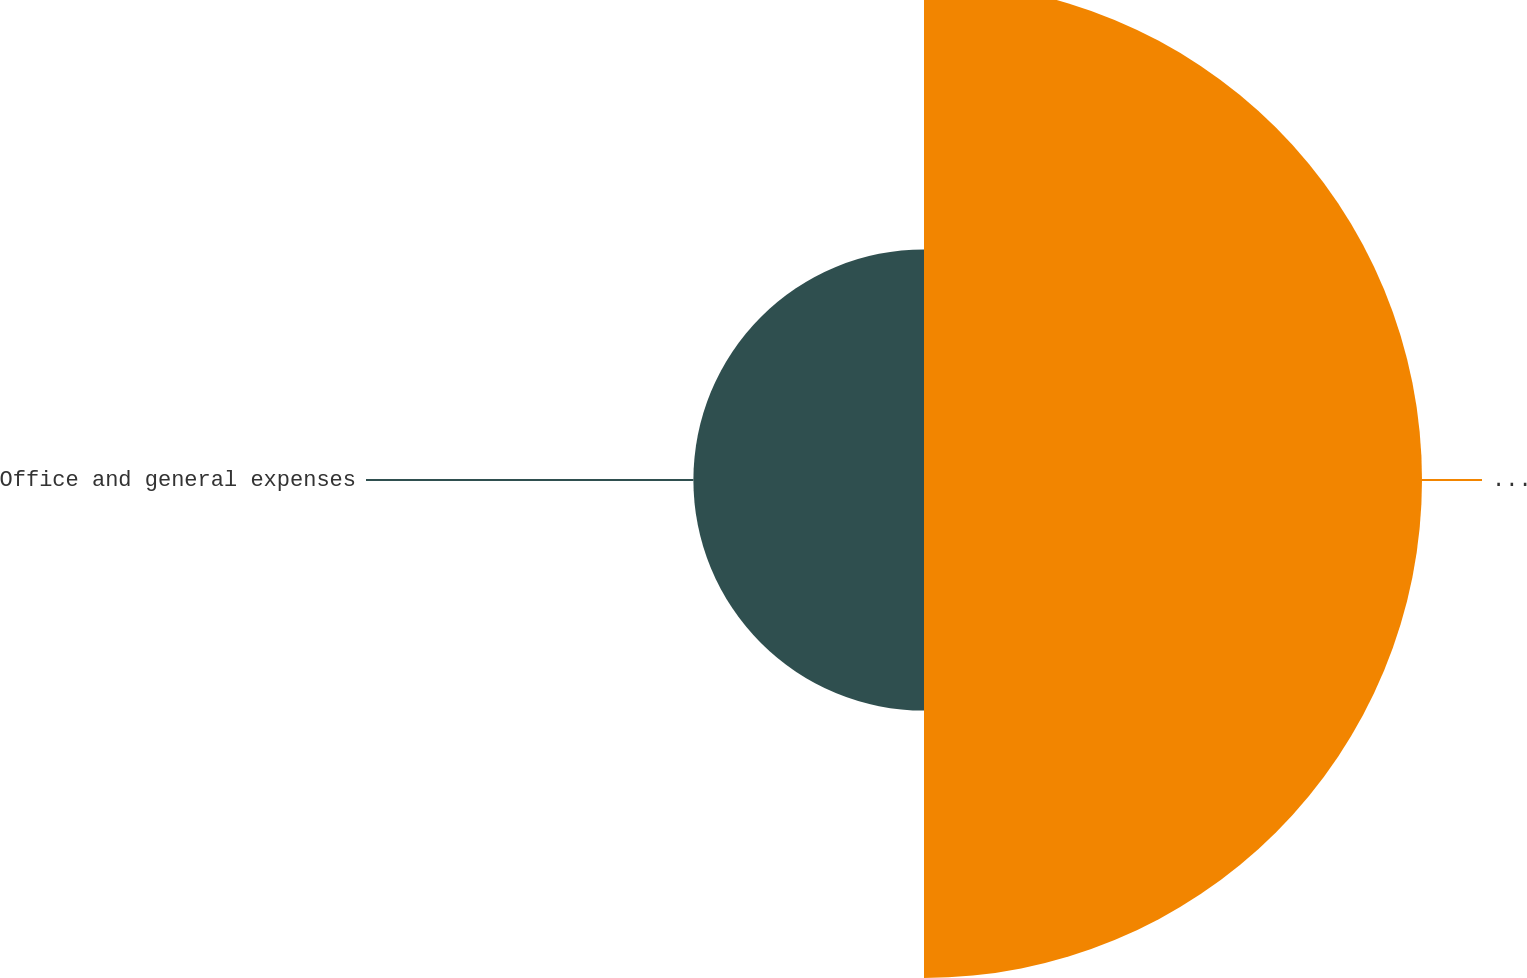<chart> <loc_0><loc_0><loc_500><loc_500><pie_chart><fcel>Salaries and related expenses<fcel>Office and general expenses<nl><fcel>68.35%<fcel>31.65%<nl></chart> 